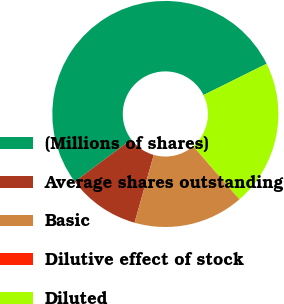Convert chart. <chart><loc_0><loc_0><loc_500><loc_500><pie_chart><fcel>(Millions of shares)<fcel>Average shares outstanding<fcel>Basic<fcel>Dilutive effect of stock<fcel>Diluted<nl><fcel>52.89%<fcel>10.4%<fcel>15.68%<fcel>0.08%<fcel>20.96%<nl></chart> 